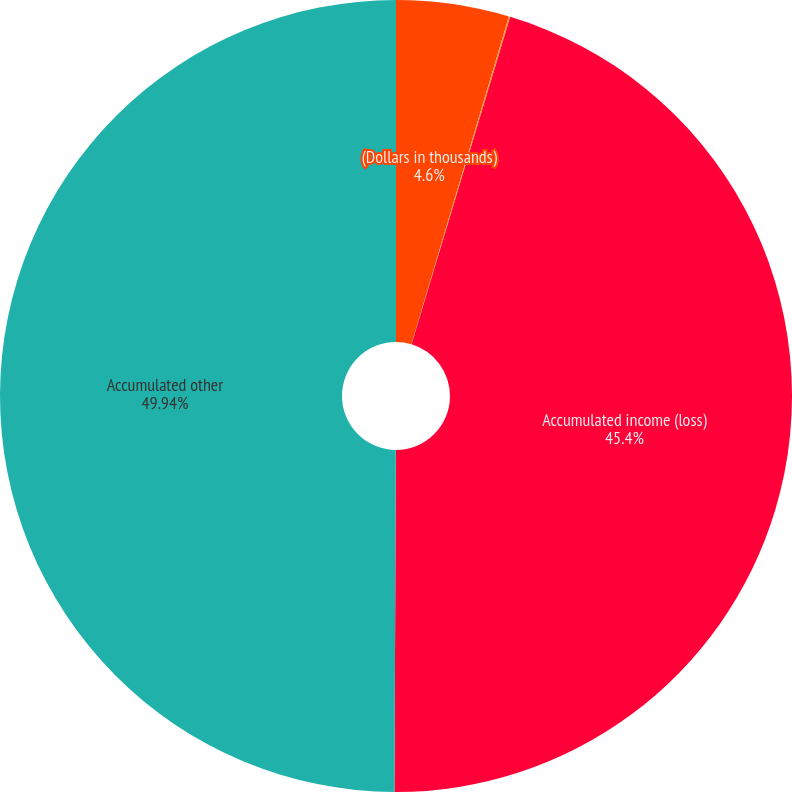<chart> <loc_0><loc_0><loc_500><loc_500><pie_chart><fcel>(Dollars in thousands)<fcel>Prior service cost<fcel>Accumulated income (loss)<fcel>Accumulated other<nl><fcel>4.6%<fcel>0.06%<fcel>45.4%<fcel>49.94%<nl></chart> 